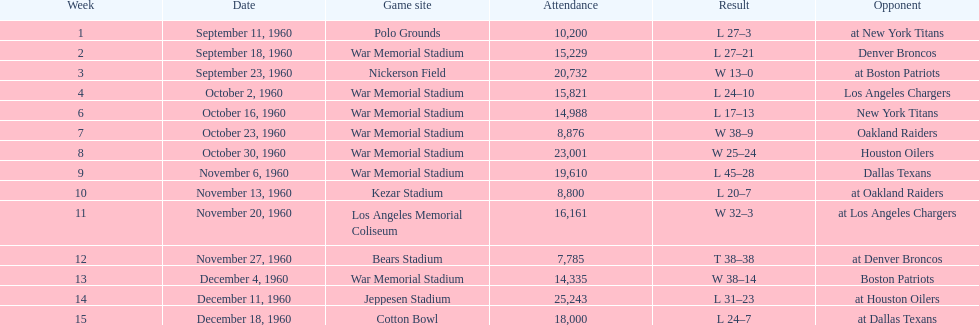How many games had at least 10,000 people in attendance? 11. 